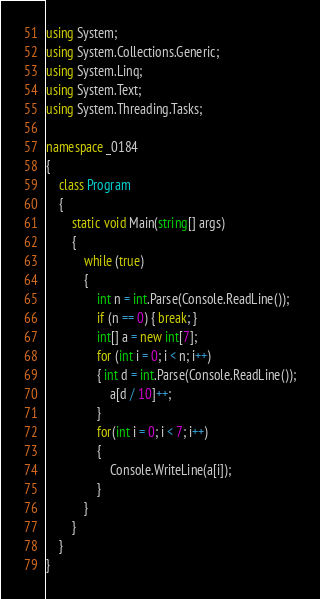Convert code to text. <code><loc_0><loc_0><loc_500><loc_500><_C#_>using System;
using System.Collections.Generic;
using System.Linq;
using System.Text;
using System.Threading.Tasks;

namespace _0184
{
    class Program
    {
        static void Main(string[] args)
        {
            while (true)
            {
                int n = int.Parse(Console.ReadLine());
                if (n == 0) { break; }
                int[] a = new int[7];
                for (int i = 0; i < n; i++)
                { int d = int.Parse(Console.ReadLine());
                    a[d / 10]++;
                }
                for(int i = 0; i < 7; i++)
                {
                    Console.WriteLine(a[i]);
                }
            }
        }
    }
}</code> 